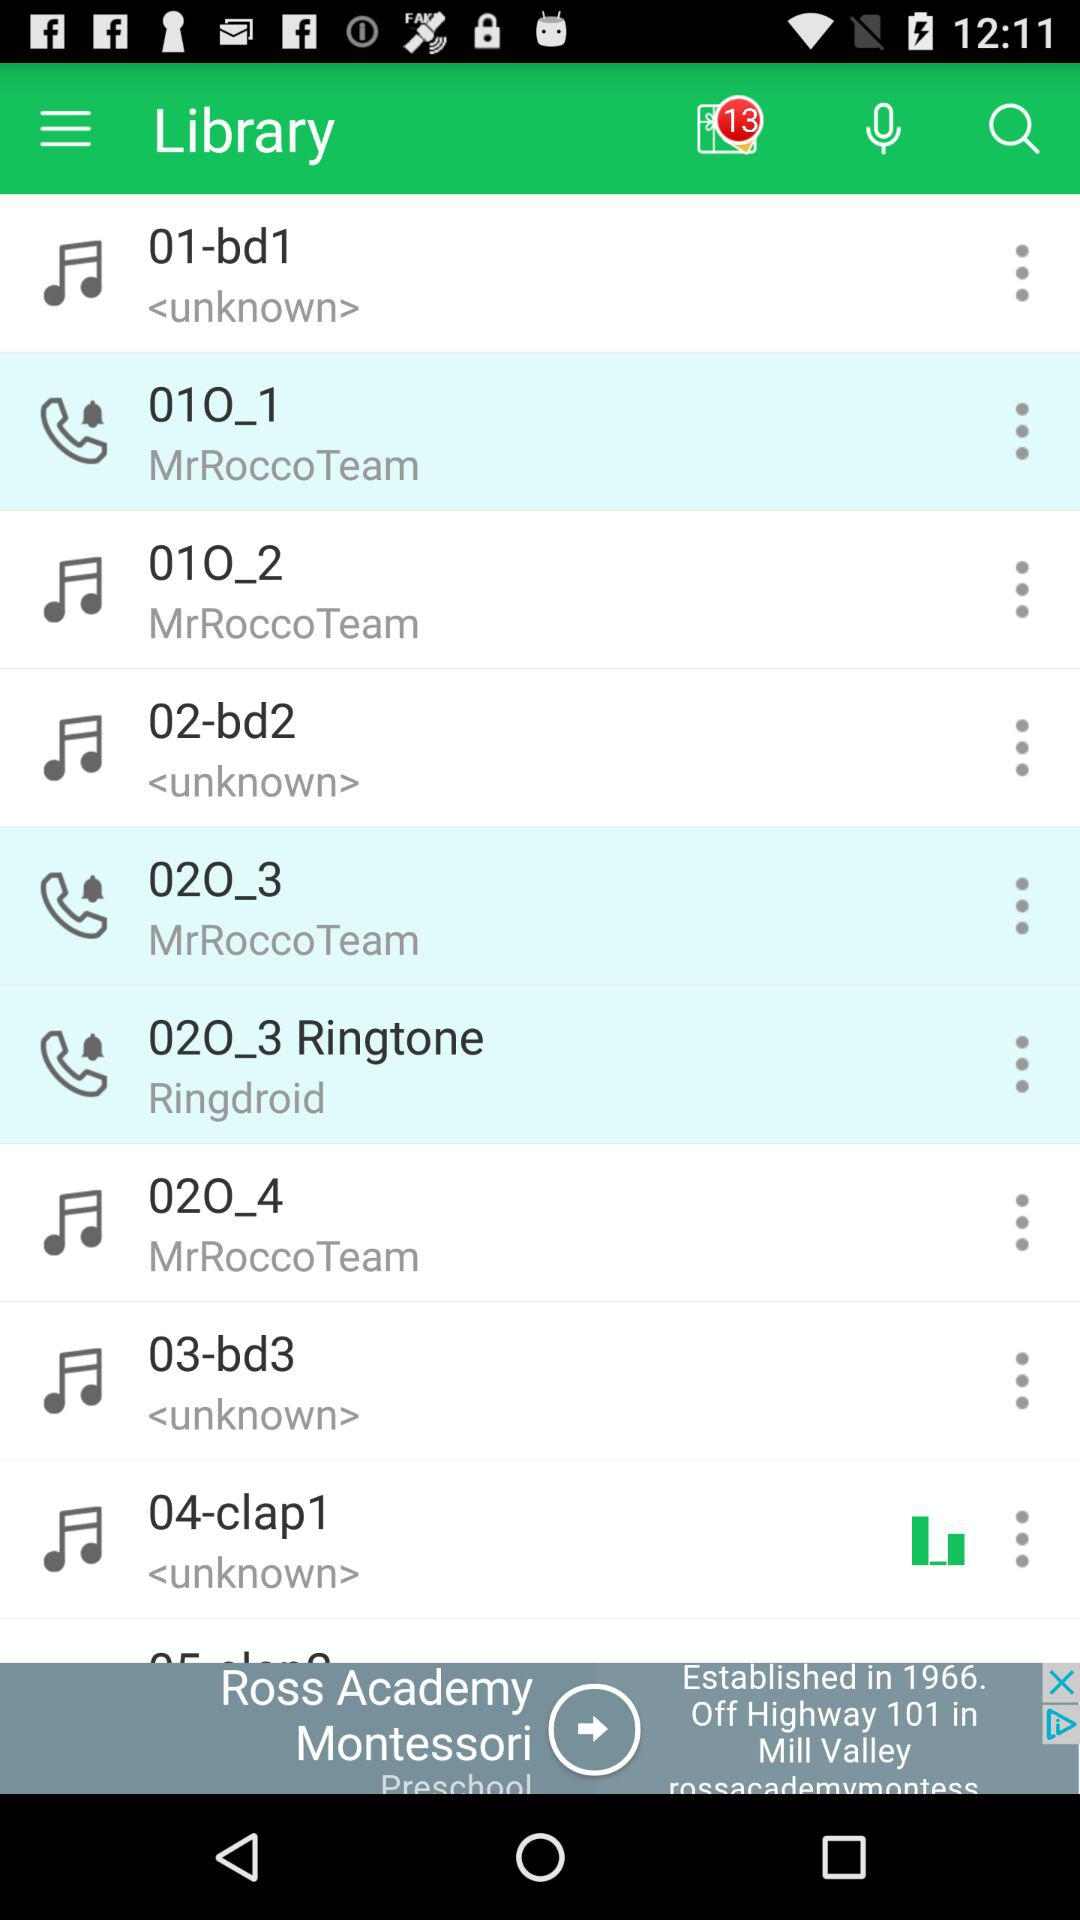What's the name of the band who gave the audio clip "02O_4"? The name of the band is "MrRoccoTeam". 